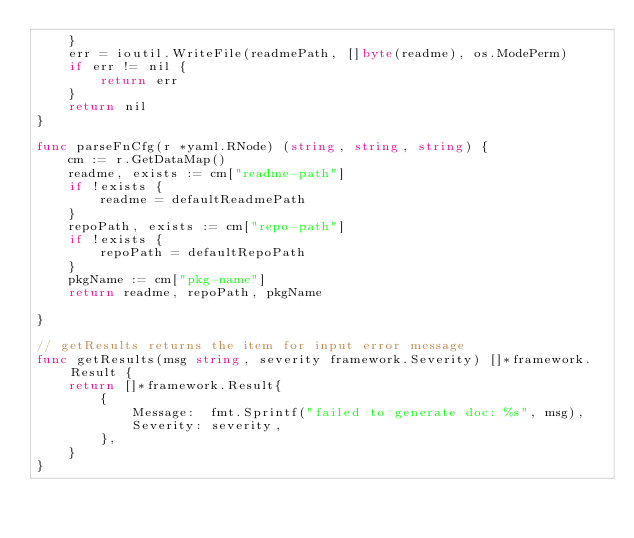<code> <loc_0><loc_0><loc_500><loc_500><_Go_>	}
	err = ioutil.WriteFile(readmePath, []byte(readme), os.ModePerm)
	if err != nil {
		return err
	}
	return nil
}

func parseFnCfg(r *yaml.RNode) (string, string, string) {
	cm := r.GetDataMap()
	readme, exists := cm["readme-path"]
	if !exists {
		readme = defaultReadmePath
	}
	repoPath, exists := cm["repo-path"]
	if !exists {
		repoPath = defaultRepoPath
	}
	pkgName := cm["pkg-name"]
	return readme, repoPath, pkgName

}

// getResults returns the item for input error message
func getResults(msg string, severity framework.Severity) []*framework.Result {
	return []*framework.Result{
		{
			Message:  fmt.Sprintf("failed to generate doc: %s", msg),
			Severity: severity,
		},
	}
}
</code> 